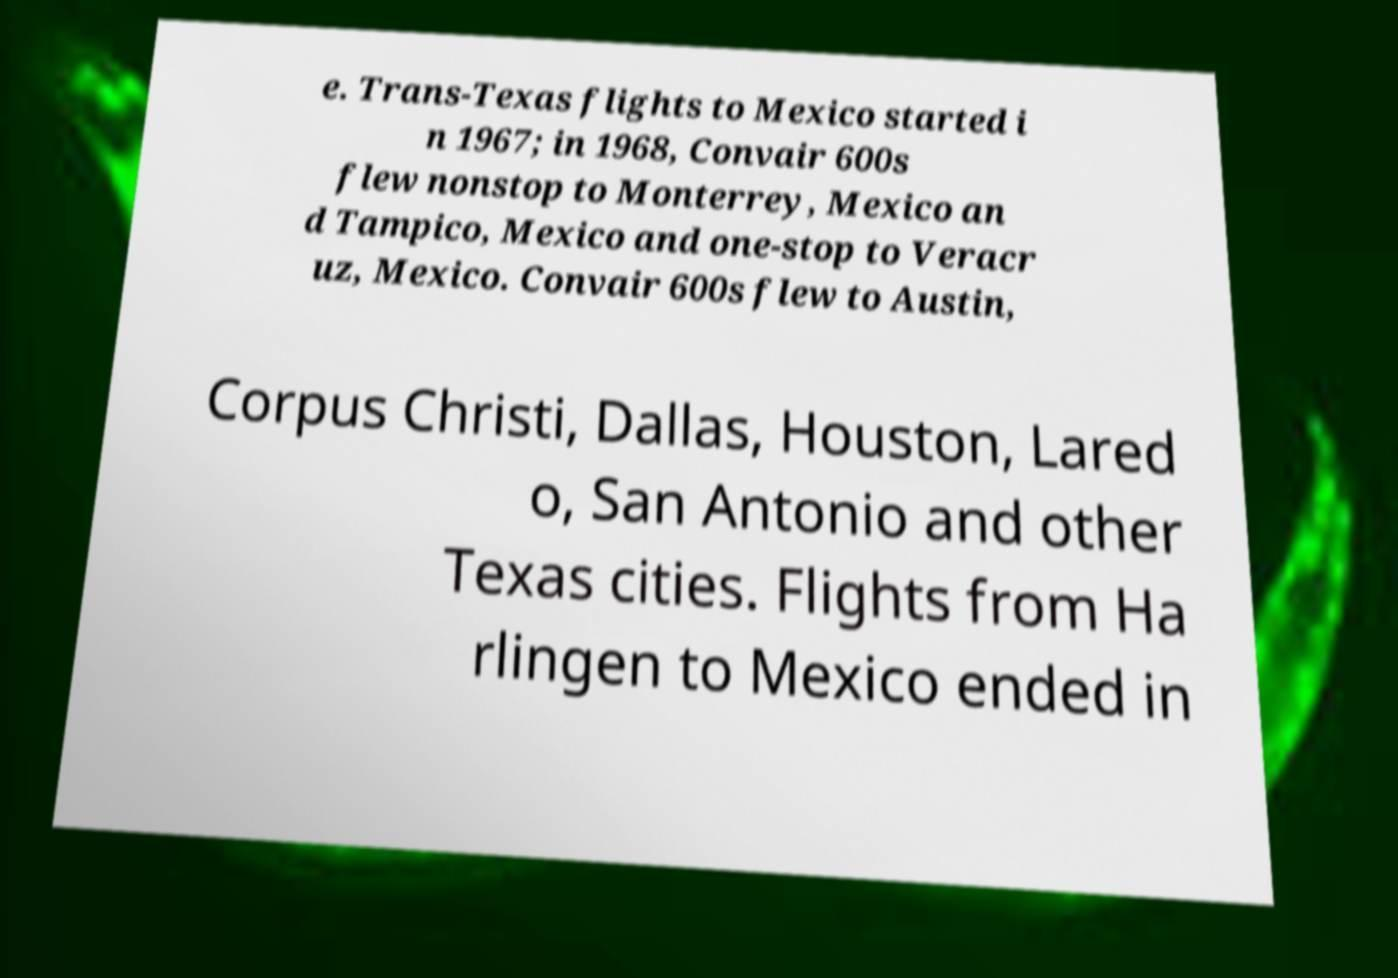Can you read and provide the text displayed in the image?This photo seems to have some interesting text. Can you extract and type it out for me? e. Trans-Texas flights to Mexico started i n 1967; in 1968, Convair 600s flew nonstop to Monterrey, Mexico an d Tampico, Mexico and one-stop to Veracr uz, Mexico. Convair 600s flew to Austin, Corpus Christi, Dallas, Houston, Lared o, San Antonio and other Texas cities. Flights from Ha rlingen to Mexico ended in 